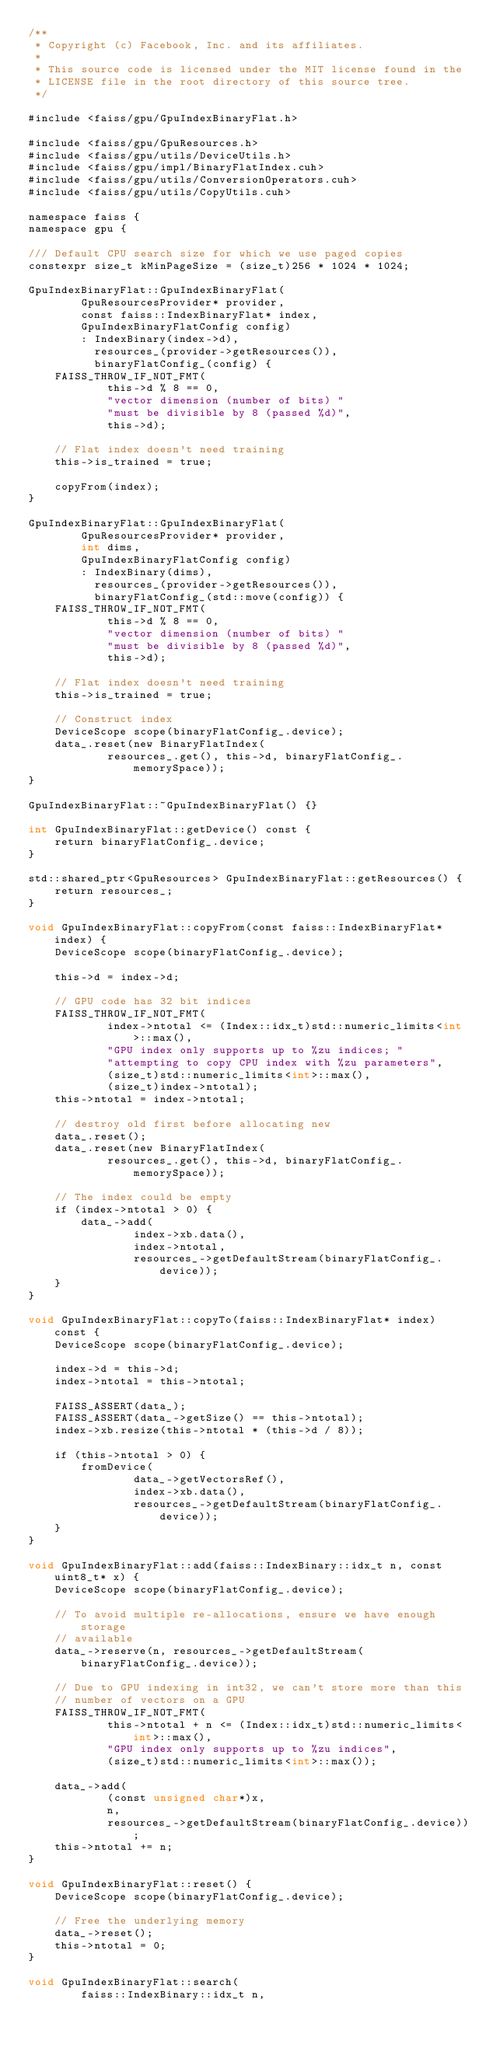Convert code to text. <code><loc_0><loc_0><loc_500><loc_500><_Cuda_>/**
 * Copyright (c) Facebook, Inc. and its affiliates.
 *
 * This source code is licensed under the MIT license found in the
 * LICENSE file in the root directory of this source tree.
 */

#include <faiss/gpu/GpuIndexBinaryFlat.h>

#include <faiss/gpu/GpuResources.h>
#include <faiss/gpu/utils/DeviceUtils.h>
#include <faiss/gpu/impl/BinaryFlatIndex.cuh>
#include <faiss/gpu/utils/ConversionOperators.cuh>
#include <faiss/gpu/utils/CopyUtils.cuh>

namespace faiss {
namespace gpu {

/// Default CPU search size for which we use paged copies
constexpr size_t kMinPageSize = (size_t)256 * 1024 * 1024;

GpuIndexBinaryFlat::GpuIndexBinaryFlat(
        GpuResourcesProvider* provider,
        const faiss::IndexBinaryFlat* index,
        GpuIndexBinaryFlatConfig config)
        : IndexBinary(index->d),
          resources_(provider->getResources()),
          binaryFlatConfig_(config) {
    FAISS_THROW_IF_NOT_FMT(
            this->d % 8 == 0,
            "vector dimension (number of bits) "
            "must be divisible by 8 (passed %d)",
            this->d);

    // Flat index doesn't need training
    this->is_trained = true;

    copyFrom(index);
}

GpuIndexBinaryFlat::GpuIndexBinaryFlat(
        GpuResourcesProvider* provider,
        int dims,
        GpuIndexBinaryFlatConfig config)
        : IndexBinary(dims),
          resources_(provider->getResources()),
          binaryFlatConfig_(std::move(config)) {
    FAISS_THROW_IF_NOT_FMT(
            this->d % 8 == 0,
            "vector dimension (number of bits) "
            "must be divisible by 8 (passed %d)",
            this->d);

    // Flat index doesn't need training
    this->is_trained = true;

    // Construct index
    DeviceScope scope(binaryFlatConfig_.device);
    data_.reset(new BinaryFlatIndex(
            resources_.get(), this->d, binaryFlatConfig_.memorySpace));
}

GpuIndexBinaryFlat::~GpuIndexBinaryFlat() {}

int GpuIndexBinaryFlat::getDevice() const {
    return binaryFlatConfig_.device;
}

std::shared_ptr<GpuResources> GpuIndexBinaryFlat::getResources() {
    return resources_;
}

void GpuIndexBinaryFlat::copyFrom(const faiss::IndexBinaryFlat* index) {
    DeviceScope scope(binaryFlatConfig_.device);

    this->d = index->d;

    // GPU code has 32 bit indices
    FAISS_THROW_IF_NOT_FMT(
            index->ntotal <= (Index::idx_t)std::numeric_limits<int>::max(),
            "GPU index only supports up to %zu indices; "
            "attempting to copy CPU index with %zu parameters",
            (size_t)std::numeric_limits<int>::max(),
            (size_t)index->ntotal);
    this->ntotal = index->ntotal;

    // destroy old first before allocating new
    data_.reset();
    data_.reset(new BinaryFlatIndex(
            resources_.get(), this->d, binaryFlatConfig_.memorySpace));

    // The index could be empty
    if (index->ntotal > 0) {
        data_->add(
                index->xb.data(),
                index->ntotal,
                resources_->getDefaultStream(binaryFlatConfig_.device));
    }
}

void GpuIndexBinaryFlat::copyTo(faiss::IndexBinaryFlat* index) const {
    DeviceScope scope(binaryFlatConfig_.device);

    index->d = this->d;
    index->ntotal = this->ntotal;

    FAISS_ASSERT(data_);
    FAISS_ASSERT(data_->getSize() == this->ntotal);
    index->xb.resize(this->ntotal * (this->d / 8));

    if (this->ntotal > 0) {
        fromDevice(
                data_->getVectorsRef(),
                index->xb.data(),
                resources_->getDefaultStream(binaryFlatConfig_.device));
    }
}

void GpuIndexBinaryFlat::add(faiss::IndexBinary::idx_t n, const uint8_t* x) {
    DeviceScope scope(binaryFlatConfig_.device);

    // To avoid multiple re-allocations, ensure we have enough storage
    // available
    data_->reserve(n, resources_->getDefaultStream(binaryFlatConfig_.device));

    // Due to GPU indexing in int32, we can't store more than this
    // number of vectors on a GPU
    FAISS_THROW_IF_NOT_FMT(
            this->ntotal + n <= (Index::idx_t)std::numeric_limits<int>::max(),
            "GPU index only supports up to %zu indices",
            (size_t)std::numeric_limits<int>::max());

    data_->add(
            (const unsigned char*)x,
            n,
            resources_->getDefaultStream(binaryFlatConfig_.device));
    this->ntotal += n;
}

void GpuIndexBinaryFlat::reset() {
    DeviceScope scope(binaryFlatConfig_.device);

    // Free the underlying memory
    data_->reset();
    this->ntotal = 0;
}

void GpuIndexBinaryFlat::search(
        faiss::IndexBinary::idx_t n,</code> 